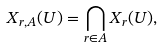<formula> <loc_0><loc_0><loc_500><loc_500>X _ { r , A } ( U ) = \bigcap _ { r \in A } X _ { r } ( U ) ,</formula> 